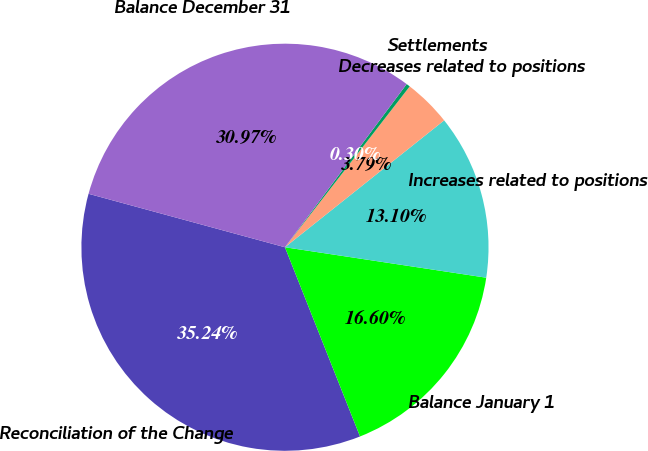<chart> <loc_0><loc_0><loc_500><loc_500><pie_chart><fcel>Reconciliation of the Change<fcel>Balance January 1<fcel>Increases related to positions<fcel>Decreases related to positions<fcel>Settlements<fcel>Balance December 31<nl><fcel>35.24%<fcel>16.6%<fcel>13.1%<fcel>3.79%<fcel>0.3%<fcel>30.97%<nl></chart> 